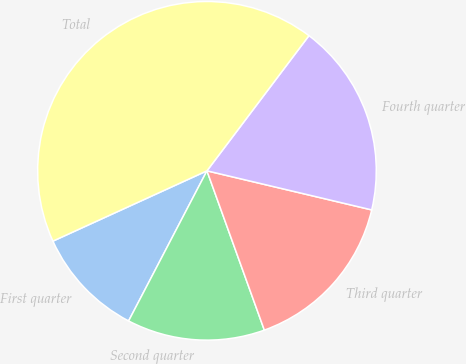Convert chart to OTSL. <chart><loc_0><loc_0><loc_500><loc_500><pie_chart><fcel>First quarter<fcel>Second quarter<fcel>Third quarter<fcel>Fourth quarter<fcel>Total<nl><fcel>10.53%<fcel>13.16%<fcel>15.79%<fcel>18.42%<fcel>42.11%<nl></chart> 